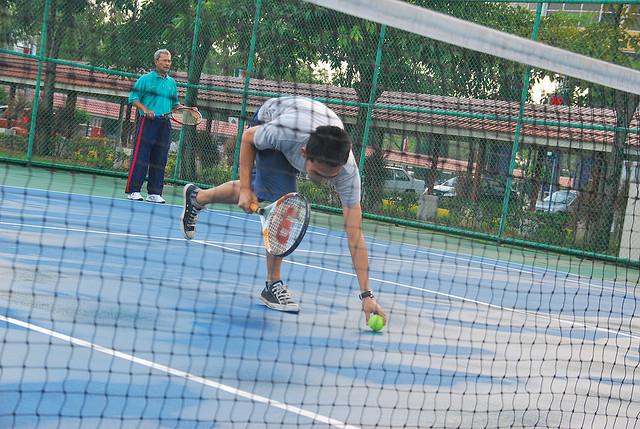Are there spectators?
Keep it brief. No. Is the ball on the ground?
Keep it brief. Yes. What color is the net?
Keep it brief. Black. What the man bending to pick up?
Keep it brief. Tennis ball. What sport is this?
Short answer required. Tennis. 